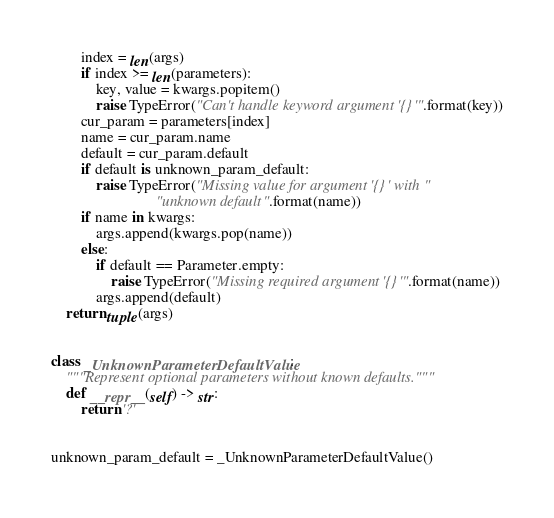Convert code to text. <code><loc_0><loc_0><loc_500><loc_500><_Python_>        index = len(args)
        if index >= len(parameters):
            key, value = kwargs.popitem()
            raise TypeError("Can't handle keyword argument '{}'".format(key))
        cur_param = parameters[index]
        name = cur_param.name
        default = cur_param.default
        if default is unknown_param_default:
            raise TypeError("Missing value for argument '{}' with "
                            "unknown default".format(name))
        if name in kwargs:
            args.append(kwargs.pop(name))
        else:
            if default == Parameter.empty:
                raise TypeError("Missing required argument '{}'".format(name))
            args.append(default)
    return tuple(args)


class _UnknownParameterDefaultValue:
    """Represent optional parameters without known defaults."""
    def __repr__(self) -> str:
        return '?'


unknown_param_default = _UnknownParameterDefaultValue()
</code> 